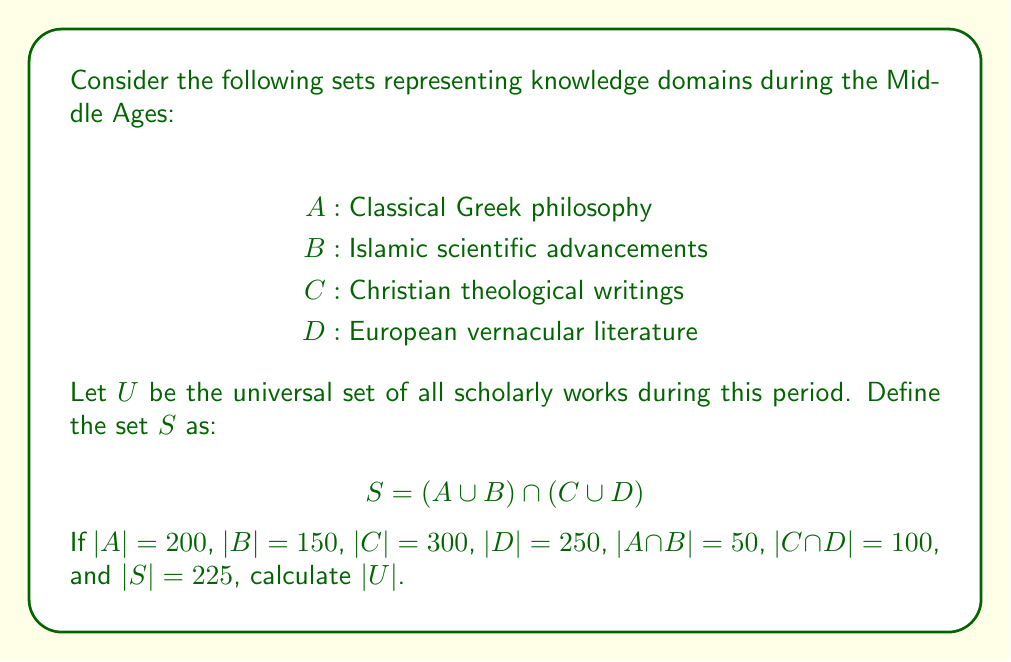Help me with this question. To solve this problem, we'll use the Inclusion-Exclusion Principle and set theory operations. Let's break it down step-by-step:

1) First, let's calculate $|A \cup B|$ and $|C \cup D|$:

   $|A \cup B| = |A| + |B| - |A \cap B| = 200 + 150 - 50 = 300$
   $|C \cup D| = |C| + |D| - |C \cap D| = 300 + 250 - 100 = 450$

2) Now, we know that $S = (A \cup B) \cap (C \cup D)$ and $|S| = 225$. We can use this to find $|(A \cup B) \cup (C \cup D)|$:

   $|(A \cup B) \cup (C \cup D)| = |A \cup B| + |C \cup D| - |S|$
   $= 300 + 450 - 225 = 525$

3) Now, let's define $X = (A \cup B) \cup (C \cup D)$. We know that $|X| = 525$.

4) The universal set $U$ contains all elements, including those not in $X$. So:

   $|U| = |X| + |U \setminus X|$

5) We don't know $|U \setminus X|$ directly, but we can deduce it. The set $U \setminus X$ represents scholarly works that are not in any of $A$, $B$, $C$, or $D$. This could include works from other cultures or disciplines not captured in these four categories.

6) Given the persona of a scholar arguing against the "Dark Ages" concept, we can reasonably assume that $|U \setminus X|$ is significant, representing a diverse body of knowledge outside the traditional categories. Let's estimate it as 30% of $|X|$:

   $|U \setminus X| \approx 0.3 * |X| = 0.3 * 525 = 157.5$

7) Rounding to the nearest whole number (as we're dealing with discrete works):

   $|U \setminus X| \approx 158$

8) Finally, we can calculate $|U|$:

   $|U| = |X| + |U \setminus X| = 525 + 158 = 683$
Answer: $|U| = 683$ 